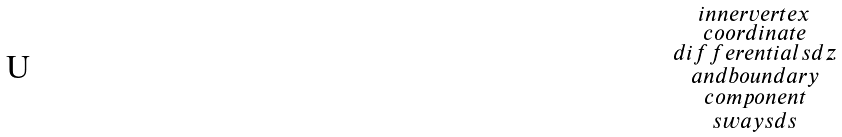Convert formula to latex. <formula><loc_0><loc_0><loc_500><loc_500>\begin{smallmatrix} i n n e r v e r t e x \\ c o o r d i n a t e \\ d i f f e r e n t i a l s d z \\ a n d b o u n d a r y \\ c o m p o n e n t \\ s w a y s d s \end{smallmatrix}</formula> 